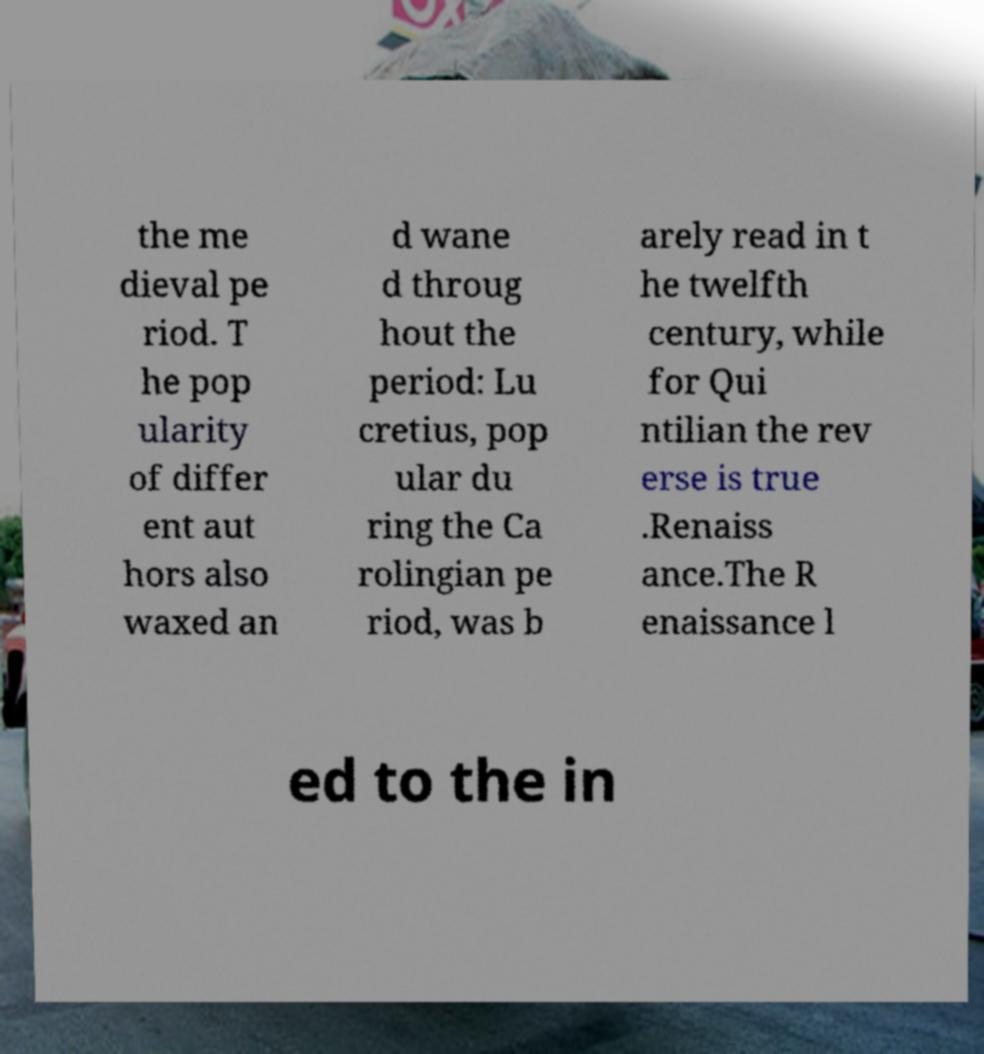Can you read and provide the text displayed in the image?This photo seems to have some interesting text. Can you extract and type it out for me? the me dieval pe riod. T he pop ularity of differ ent aut hors also waxed an d wane d throug hout the period: Lu cretius, pop ular du ring the Ca rolingian pe riod, was b arely read in t he twelfth century, while for Qui ntilian the rev erse is true .Renaiss ance.The R enaissance l ed to the in 